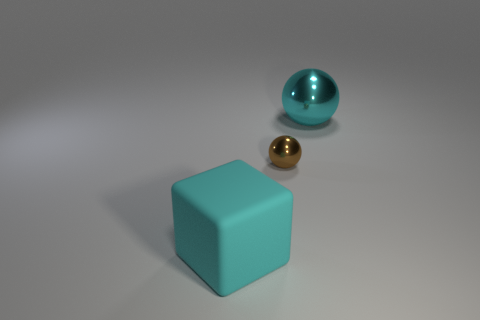There is a matte thing that is the same size as the cyan shiny ball; what is its color? The matte object that matches the size of the shiny cyan ball is, in fact, turquoise in color. 